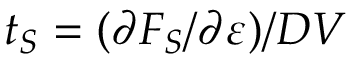Convert formula to latex. <formula><loc_0><loc_0><loc_500><loc_500>t _ { S } = ( \partial F _ { S } / \partial \varepsilon ) / D V</formula> 